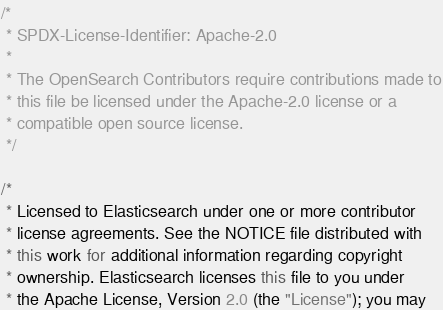<code> <loc_0><loc_0><loc_500><loc_500><_Java_>/*
 * SPDX-License-Identifier: Apache-2.0
 *
 * The OpenSearch Contributors require contributions made to
 * this file be licensed under the Apache-2.0 license or a
 * compatible open source license.
 */

/*
 * Licensed to Elasticsearch under one or more contributor
 * license agreements. See the NOTICE file distributed with
 * this work for additional information regarding copyright
 * ownership. Elasticsearch licenses this file to you under
 * the Apache License, Version 2.0 (the "License"); you may</code> 